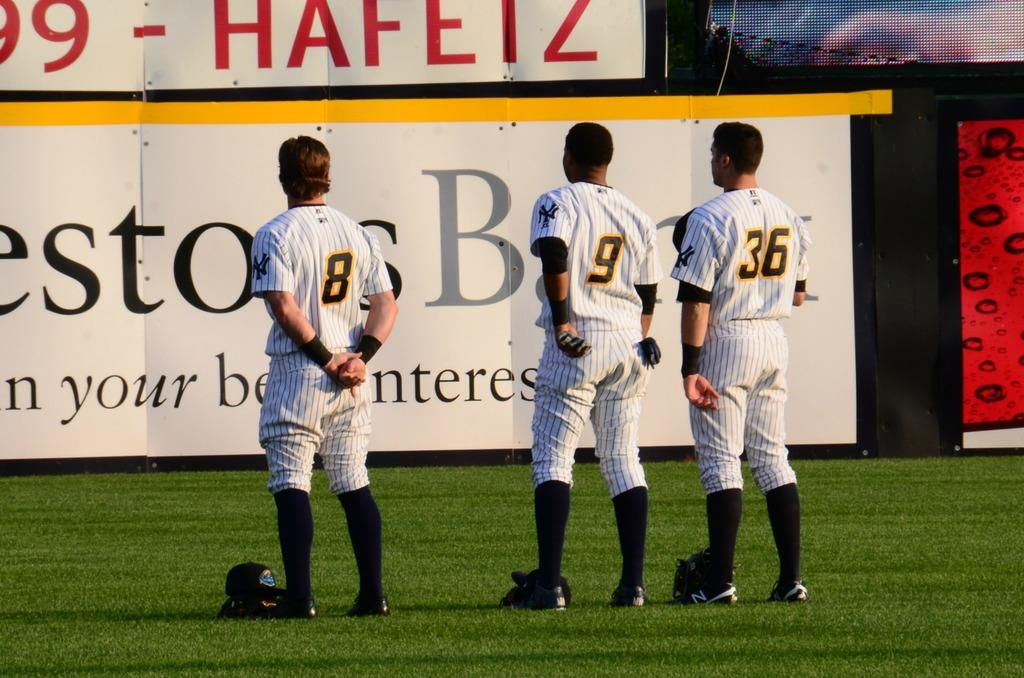<image>
Provide a brief description of the given image. A group of three baseball players facing an advertisement with the numbers 8,9, and 36 on the back of their shirts 